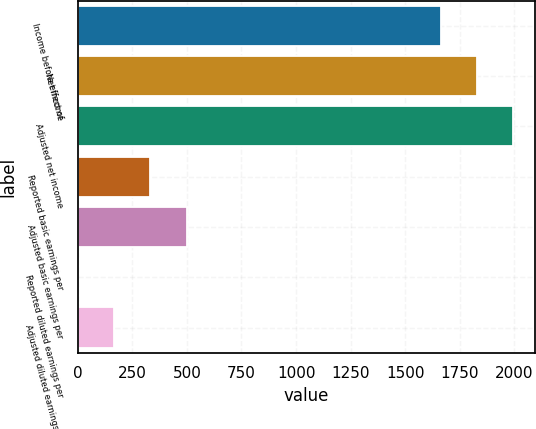Convert chart. <chart><loc_0><loc_0><loc_500><loc_500><bar_chart><fcel>Income before effect of<fcel>Net income<fcel>Adjusted net income<fcel>Reported basic earnings per<fcel>Adjusted basic earnings per<fcel>Reported diluted earnings per<fcel>Adjusted diluted earnings per<nl><fcel>1663<fcel>1829.22<fcel>1995.44<fcel>333.24<fcel>499.46<fcel>0.8<fcel>167.02<nl></chart> 